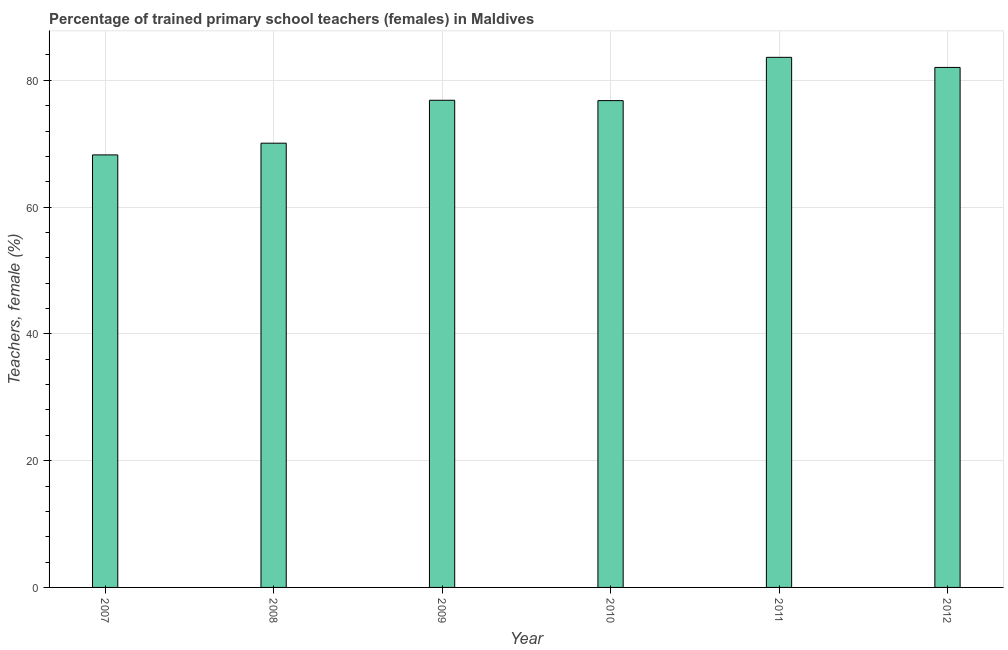Does the graph contain any zero values?
Offer a very short reply. No. Does the graph contain grids?
Provide a succinct answer. Yes. What is the title of the graph?
Ensure brevity in your answer.  Percentage of trained primary school teachers (females) in Maldives. What is the label or title of the X-axis?
Ensure brevity in your answer.  Year. What is the label or title of the Y-axis?
Offer a terse response. Teachers, female (%). What is the percentage of trained female teachers in 2007?
Your answer should be compact. 68.23. Across all years, what is the maximum percentage of trained female teachers?
Give a very brief answer. 83.62. Across all years, what is the minimum percentage of trained female teachers?
Offer a very short reply. 68.23. What is the sum of the percentage of trained female teachers?
Offer a very short reply. 457.61. What is the difference between the percentage of trained female teachers in 2008 and 2012?
Make the answer very short. -11.95. What is the average percentage of trained female teachers per year?
Provide a succinct answer. 76.27. What is the median percentage of trained female teachers?
Your answer should be compact. 76.82. In how many years, is the percentage of trained female teachers greater than 8 %?
Keep it short and to the point. 6. What is the ratio of the percentage of trained female teachers in 2008 to that in 2010?
Make the answer very short. 0.91. Is the percentage of trained female teachers in 2007 less than that in 2010?
Ensure brevity in your answer.  Yes. What is the difference between the highest and the second highest percentage of trained female teachers?
Ensure brevity in your answer.  1.59. What is the difference between the highest and the lowest percentage of trained female teachers?
Offer a very short reply. 15.39. In how many years, is the percentage of trained female teachers greater than the average percentage of trained female teachers taken over all years?
Your answer should be compact. 4. How many bars are there?
Provide a short and direct response. 6. Are all the bars in the graph horizontal?
Your answer should be very brief. No. How many years are there in the graph?
Ensure brevity in your answer.  6. What is the Teachers, female (%) in 2007?
Keep it short and to the point. 68.23. What is the Teachers, female (%) of 2008?
Your response must be concise. 70.08. What is the Teachers, female (%) in 2009?
Keep it short and to the point. 76.85. What is the Teachers, female (%) of 2010?
Offer a very short reply. 76.8. What is the Teachers, female (%) of 2011?
Give a very brief answer. 83.62. What is the Teachers, female (%) in 2012?
Offer a terse response. 82.03. What is the difference between the Teachers, female (%) in 2007 and 2008?
Provide a succinct answer. -1.85. What is the difference between the Teachers, female (%) in 2007 and 2009?
Give a very brief answer. -8.62. What is the difference between the Teachers, female (%) in 2007 and 2010?
Your answer should be very brief. -8.56. What is the difference between the Teachers, female (%) in 2007 and 2011?
Your answer should be compact. -15.39. What is the difference between the Teachers, female (%) in 2007 and 2012?
Offer a terse response. -13.8. What is the difference between the Teachers, female (%) in 2008 and 2009?
Provide a short and direct response. -6.77. What is the difference between the Teachers, female (%) in 2008 and 2010?
Give a very brief answer. -6.71. What is the difference between the Teachers, female (%) in 2008 and 2011?
Ensure brevity in your answer.  -13.54. What is the difference between the Teachers, female (%) in 2008 and 2012?
Keep it short and to the point. -11.95. What is the difference between the Teachers, female (%) in 2009 and 2010?
Make the answer very short. 0.05. What is the difference between the Teachers, female (%) in 2009 and 2011?
Provide a short and direct response. -6.78. What is the difference between the Teachers, female (%) in 2009 and 2012?
Offer a very short reply. -5.18. What is the difference between the Teachers, female (%) in 2010 and 2011?
Your answer should be compact. -6.83. What is the difference between the Teachers, female (%) in 2010 and 2012?
Keep it short and to the point. -5.24. What is the difference between the Teachers, female (%) in 2011 and 2012?
Make the answer very short. 1.59. What is the ratio of the Teachers, female (%) in 2007 to that in 2008?
Your response must be concise. 0.97. What is the ratio of the Teachers, female (%) in 2007 to that in 2009?
Keep it short and to the point. 0.89. What is the ratio of the Teachers, female (%) in 2007 to that in 2010?
Give a very brief answer. 0.89. What is the ratio of the Teachers, female (%) in 2007 to that in 2011?
Make the answer very short. 0.82. What is the ratio of the Teachers, female (%) in 2007 to that in 2012?
Your answer should be very brief. 0.83. What is the ratio of the Teachers, female (%) in 2008 to that in 2009?
Your response must be concise. 0.91. What is the ratio of the Teachers, female (%) in 2008 to that in 2011?
Give a very brief answer. 0.84. What is the ratio of the Teachers, female (%) in 2008 to that in 2012?
Your response must be concise. 0.85. What is the ratio of the Teachers, female (%) in 2009 to that in 2011?
Keep it short and to the point. 0.92. What is the ratio of the Teachers, female (%) in 2009 to that in 2012?
Ensure brevity in your answer.  0.94. What is the ratio of the Teachers, female (%) in 2010 to that in 2011?
Offer a very short reply. 0.92. What is the ratio of the Teachers, female (%) in 2010 to that in 2012?
Provide a succinct answer. 0.94. 